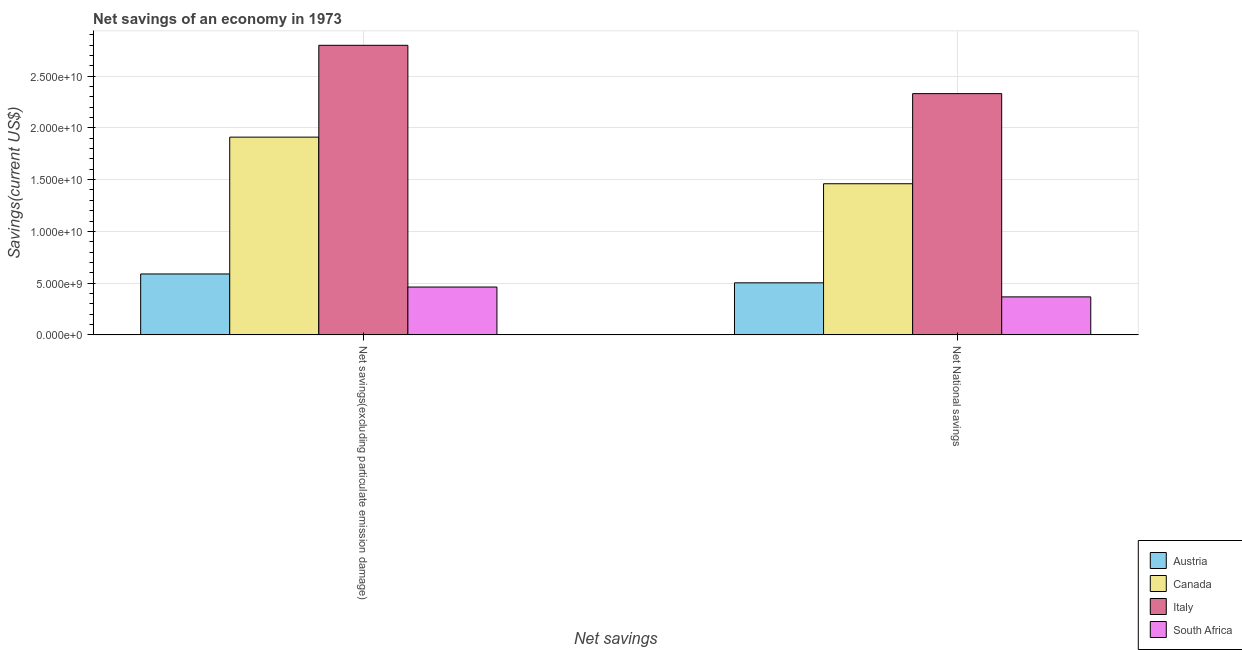Are the number of bars per tick equal to the number of legend labels?
Ensure brevity in your answer.  Yes. Are the number of bars on each tick of the X-axis equal?
Provide a short and direct response. Yes. How many bars are there on the 1st tick from the right?
Ensure brevity in your answer.  4. What is the label of the 2nd group of bars from the left?
Your answer should be compact. Net National savings. What is the net savings(excluding particulate emission damage) in Canada?
Provide a short and direct response. 1.91e+1. Across all countries, what is the maximum net national savings?
Keep it short and to the point. 2.33e+1. Across all countries, what is the minimum net national savings?
Give a very brief answer. 3.67e+09. In which country was the net savings(excluding particulate emission damage) minimum?
Your answer should be very brief. South Africa. What is the total net savings(excluding particulate emission damage) in the graph?
Your response must be concise. 5.76e+1. What is the difference between the net national savings in Austria and that in Canada?
Keep it short and to the point. -9.57e+09. What is the difference between the net national savings in Italy and the net savings(excluding particulate emission damage) in Austria?
Keep it short and to the point. 1.74e+1. What is the average net savings(excluding particulate emission damage) per country?
Make the answer very short. 1.44e+1. What is the difference between the net national savings and net savings(excluding particulate emission damage) in Canada?
Your answer should be compact. -4.50e+09. In how many countries, is the net national savings greater than 20000000000 US$?
Provide a short and direct response. 1. What is the ratio of the net savings(excluding particulate emission damage) in Austria to that in Italy?
Ensure brevity in your answer.  0.21. In how many countries, is the net national savings greater than the average net national savings taken over all countries?
Your answer should be compact. 2. What does the 1st bar from the left in Net National savings represents?
Offer a very short reply. Austria. What does the 3rd bar from the right in Net National savings represents?
Provide a short and direct response. Canada. How many bars are there?
Offer a very short reply. 8. Are all the bars in the graph horizontal?
Your answer should be very brief. No. How many countries are there in the graph?
Offer a terse response. 4. What is the difference between two consecutive major ticks on the Y-axis?
Offer a terse response. 5.00e+09. Are the values on the major ticks of Y-axis written in scientific E-notation?
Provide a succinct answer. Yes. Where does the legend appear in the graph?
Your answer should be very brief. Bottom right. How are the legend labels stacked?
Your answer should be compact. Vertical. What is the title of the graph?
Ensure brevity in your answer.  Net savings of an economy in 1973. What is the label or title of the X-axis?
Offer a very short reply. Net savings. What is the label or title of the Y-axis?
Offer a terse response. Savings(current US$). What is the Savings(current US$) of Austria in Net savings(excluding particulate emission damage)?
Provide a succinct answer. 5.89e+09. What is the Savings(current US$) in Canada in Net savings(excluding particulate emission damage)?
Ensure brevity in your answer.  1.91e+1. What is the Savings(current US$) in Italy in Net savings(excluding particulate emission damage)?
Provide a succinct answer. 2.80e+1. What is the Savings(current US$) in South Africa in Net savings(excluding particulate emission damage)?
Make the answer very short. 4.62e+09. What is the Savings(current US$) of Austria in Net National savings?
Offer a very short reply. 5.03e+09. What is the Savings(current US$) of Canada in Net National savings?
Make the answer very short. 1.46e+1. What is the Savings(current US$) of Italy in Net National savings?
Make the answer very short. 2.33e+1. What is the Savings(current US$) in South Africa in Net National savings?
Ensure brevity in your answer.  3.67e+09. Across all Net savings, what is the maximum Savings(current US$) in Austria?
Your answer should be compact. 5.89e+09. Across all Net savings, what is the maximum Savings(current US$) of Canada?
Offer a terse response. 1.91e+1. Across all Net savings, what is the maximum Savings(current US$) in Italy?
Make the answer very short. 2.80e+1. Across all Net savings, what is the maximum Savings(current US$) in South Africa?
Your answer should be very brief. 4.62e+09. Across all Net savings, what is the minimum Savings(current US$) of Austria?
Provide a succinct answer. 5.03e+09. Across all Net savings, what is the minimum Savings(current US$) in Canada?
Offer a terse response. 1.46e+1. Across all Net savings, what is the minimum Savings(current US$) of Italy?
Ensure brevity in your answer.  2.33e+1. Across all Net savings, what is the minimum Savings(current US$) of South Africa?
Keep it short and to the point. 3.67e+09. What is the total Savings(current US$) in Austria in the graph?
Your response must be concise. 1.09e+1. What is the total Savings(current US$) in Canada in the graph?
Your answer should be compact. 3.37e+1. What is the total Savings(current US$) in Italy in the graph?
Give a very brief answer. 5.13e+1. What is the total Savings(current US$) in South Africa in the graph?
Provide a short and direct response. 8.29e+09. What is the difference between the Savings(current US$) in Austria in Net savings(excluding particulate emission damage) and that in Net National savings?
Provide a short and direct response. 8.57e+08. What is the difference between the Savings(current US$) in Canada in Net savings(excluding particulate emission damage) and that in Net National savings?
Make the answer very short. 4.50e+09. What is the difference between the Savings(current US$) of Italy in Net savings(excluding particulate emission damage) and that in Net National savings?
Your response must be concise. 4.67e+09. What is the difference between the Savings(current US$) in South Africa in Net savings(excluding particulate emission damage) and that in Net National savings?
Provide a short and direct response. 9.50e+08. What is the difference between the Savings(current US$) of Austria in Net savings(excluding particulate emission damage) and the Savings(current US$) of Canada in Net National savings?
Your answer should be very brief. -8.72e+09. What is the difference between the Savings(current US$) of Austria in Net savings(excluding particulate emission damage) and the Savings(current US$) of Italy in Net National savings?
Your answer should be very brief. -1.74e+1. What is the difference between the Savings(current US$) in Austria in Net savings(excluding particulate emission damage) and the Savings(current US$) in South Africa in Net National savings?
Your response must be concise. 2.21e+09. What is the difference between the Savings(current US$) in Canada in Net savings(excluding particulate emission damage) and the Savings(current US$) in Italy in Net National savings?
Give a very brief answer. -4.20e+09. What is the difference between the Savings(current US$) in Canada in Net savings(excluding particulate emission damage) and the Savings(current US$) in South Africa in Net National savings?
Offer a very short reply. 1.54e+1. What is the difference between the Savings(current US$) in Italy in Net savings(excluding particulate emission damage) and the Savings(current US$) in South Africa in Net National savings?
Give a very brief answer. 2.43e+1. What is the average Savings(current US$) in Austria per Net savings?
Offer a terse response. 5.46e+09. What is the average Savings(current US$) of Canada per Net savings?
Your answer should be compact. 1.69e+1. What is the average Savings(current US$) of Italy per Net savings?
Provide a short and direct response. 2.56e+1. What is the average Savings(current US$) of South Africa per Net savings?
Provide a short and direct response. 4.15e+09. What is the difference between the Savings(current US$) in Austria and Savings(current US$) in Canada in Net savings(excluding particulate emission damage)?
Offer a very short reply. -1.32e+1. What is the difference between the Savings(current US$) of Austria and Savings(current US$) of Italy in Net savings(excluding particulate emission damage)?
Provide a short and direct response. -2.21e+1. What is the difference between the Savings(current US$) of Austria and Savings(current US$) of South Africa in Net savings(excluding particulate emission damage)?
Ensure brevity in your answer.  1.26e+09. What is the difference between the Savings(current US$) of Canada and Savings(current US$) of Italy in Net savings(excluding particulate emission damage)?
Offer a very short reply. -8.87e+09. What is the difference between the Savings(current US$) of Canada and Savings(current US$) of South Africa in Net savings(excluding particulate emission damage)?
Your answer should be very brief. 1.45e+1. What is the difference between the Savings(current US$) of Italy and Savings(current US$) of South Africa in Net savings(excluding particulate emission damage)?
Make the answer very short. 2.34e+1. What is the difference between the Savings(current US$) of Austria and Savings(current US$) of Canada in Net National savings?
Your answer should be very brief. -9.57e+09. What is the difference between the Savings(current US$) in Austria and Savings(current US$) in Italy in Net National savings?
Your answer should be very brief. -1.83e+1. What is the difference between the Savings(current US$) in Austria and Savings(current US$) in South Africa in Net National savings?
Offer a very short reply. 1.36e+09. What is the difference between the Savings(current US$) of Canada and Savings(current US$) of Italy in Net National savings?
Give a very brief answer. -8.71e+09. What is the difference between the Savings(current US$) of Canada and Savings(current US$) of South Africa in Net National savings?
Provide a succinct answer. 1.09e+1. What is the difference between the Savings(current US$) in Italy and Savings(current US$) in South Africa in Net National savings?
Your answer should be very brief. 1.96e+1. What is the ratio of the Savings(current US$) of Austria in Net savings(excluding particulate emission damage) to that in Net National savings?
Your answer should be very brief. 1.17. What is the ratio of the Savings(current US$) in Canada in Net savings(excluding particulate emission damage) to that in Net National savings?
Provide a succinct answer. 1.31. What is the ratio of the Savings(current US$) in Italy in Net savings(excluding particulate emission damage) to that in Net National savings?
Your answer should be compact. 1.2. What is the ratio of the Savings(current US$) in South Africa in Net savings(excluding particulate emission damage) to that in Net National savings?
Provide a succinct answer. 1.26. What is the difference between the highest and the second highest Savings(current US$) of Austria?
Your answer should be compact. 8.57e+08. What is the difference between the highest and the second highest Savings(current US$) of Canada?
Your response must be concise. 4.50e+09. What is the difference between the highest and the second highest Savings(current US$) of Italy?
Offer a very short reply. 4.67e+09. What is the difference between the highest and the second highest Savings(current US$) in South Africa?
Give a very brief answer. 9.50e+08. What is the difference between the highest and the lowest Savings(current US$) in Austria?
Offer a terse response. 8.57e+08. What is the difference between the highest and the lowest Savings(current US$) in Canada?
Provide a succinct answer. 4.50e+09. What is the difference between the highest and the lowest Savings(current US$) in Italy?
Your response must be concise. 4.67e+09. What is the difference between the highest and the lowest Savings(current US$) of South Africa?
Give a very brief answer. 9.50e+08. 